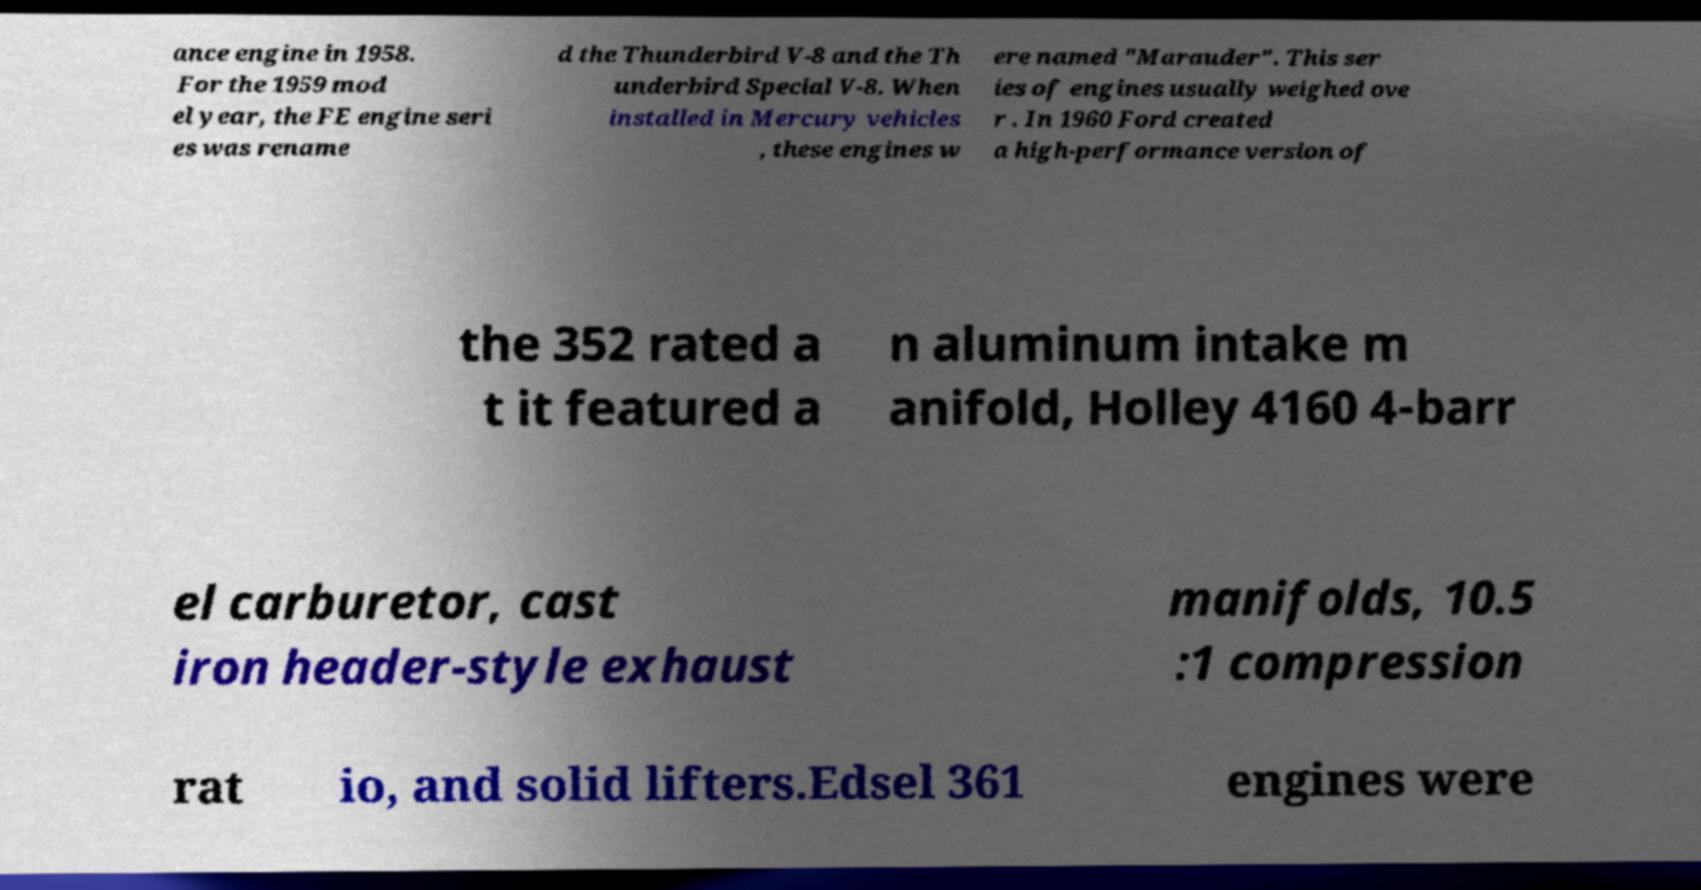What messages or text are displayed in this image? I need them in a readable, typed format. ance engine in 1958. For the 1959 mod el year, the FE engine seri es was rename d the Thunderbird V-8 and the Th underbird Special V-8. When installed in Mercury vehicles , these engines w ere named "Marauder". This ser ies of engines usually weighed ove r . In 1960 Ford created a high-performance version of the 352 rated a t it featured a n aluminum intake m anifold, Holley 4160 4-barr el carburetor, cast iron header-style exhaust manifolds, 10.5 :1 compression rat io, and solid lifters.Edsel 361 engines were 